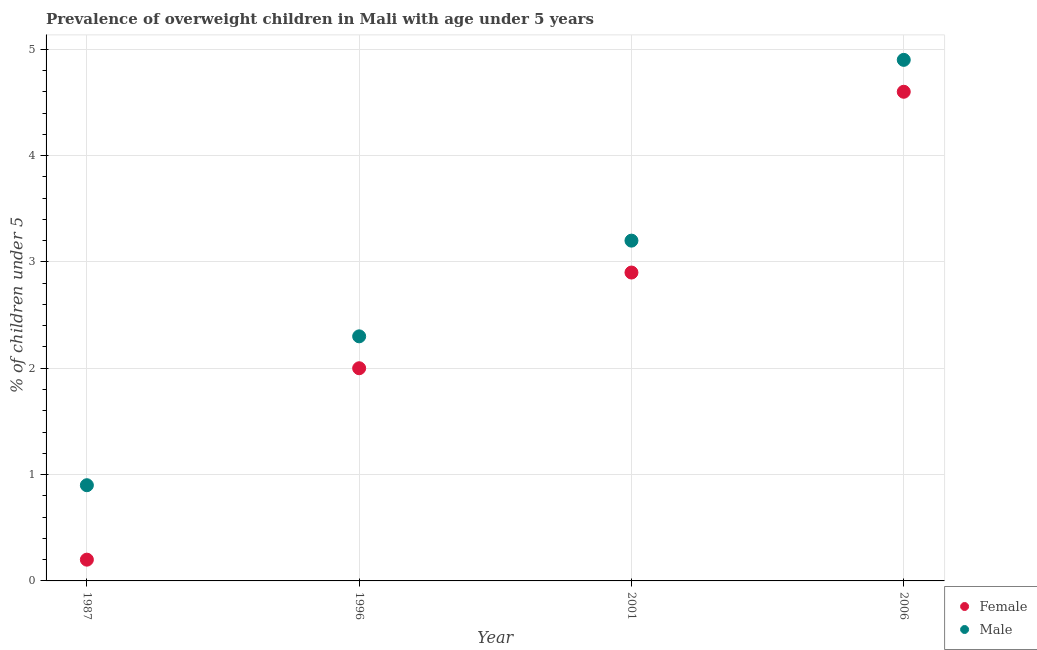How many different coloured dotlines are there?
Give a very brief answer. 2. What is the percentage of obese male children in 1996?
Keep it short and to the point. 2.3. Across all years, what is the maximum percentage of obese male children?
Give a very brief answer. 4.9. Across all years, what is the minimum percentage of obese female children?
Keep it short and to the point. 0.2. In which year was the percentage of obese male children maximum?
Give a very brief answer. 2006. In which year was the percentage of obese male children minimum?
Offer a terse response. 1987. What is the total percentage of obese male children in the graph?
Your response must be concise. 11.3. What is the difference between the percentage of obese female children in 1996 and that in 2006?
Your response must be concise. -2.6. What is the difference between the percentage of obese female children in 2001 and the percentage of obese male children in 1996?
Offer a terse response. 0.6. What is the average percentage of obese female children per year?
Offer a terse response. 2.43. In the year 1996, what is the difference between the percentage of obese male children and percentage of obese female children?
Offer a terse response. 0.3. In how many years, is the percentage of obese male children greater than 3 %?
Offer a terse response. 2. What is the ratio of the percentage of obese male children in 1996 to that in 2001?
Offer a very short reply. 0.72. Is the percentage of obese female children in 1987 less than that in 2006?
Your answer should be very brief. Yes. What is the difference between the highest and the second highest percentage of obese male children?
Give a very brief answer. 1.7. What is the difference between the highest and the lowest percentage of obese male children?
Offer a terse response. 4. Is the sum of the percentage of obese female children in 1996 and 2001 greater than the maximum percentage of obese male children across all years?
Offer a very short reply. No. Does the percentage of obese female children monotonically increase over the years?
Give a very brief answer. Yes. Is the percentage of obese male children strictly less than the percentage of obese female children over the years?
Give a very brief answer. No. How many legend labels are there?
Make the answer very short. 2. How are the legend labels stacked?
Offer a very short reply. Vertical. What is the title of the graph?
Offer a terse response. Prevalence of overweight children in Mali with age under 5 years. What is the label or title of the Y-axis?
Ensure brevity in your answer.   % of children under 5. What is the  % of children under 5 in Female in 1987?
Keep it short and to the point. 0.2. What is the  % of children under 5 of Male in 1987?
Your answer should be compact. 0.9. What is the  % of children under 5 in Male in 1996?
Provide a short and direct response. 2.3. What is the  % of children under 5 of Female in 2001?
Provide a short and direct response. 2.9. What is the  % of children under 5 in Male in 2001?
Make the answer very short. 3.2. What is the  % of children under 5 of Female in 2006?
Your answer should be very brief. 4.6. What is the  % of children under 5 in Male in 2006?
Keep it short and to the point. 4.9. Across all years, what is the maximum  % of children under 5 of Female?
Give a very brief answer. 4.6. Across all years, what is the maximum  % of children under 5 of Male?
Make the answer very short. 4.9. Across all years, what is the minimum  % of children under 5 of Female?
Keep it short and to the point. 0.2. Across all years, what is the minimum  % of children under 5 of Male?
Your answer should be very brief. 0.9. What is the difference between the  % of children under 5 in Female in 1987 and that in 1996?
Make the answer very short. -1.8. What is the difference between the  % of children under 5 in Male in 1987 and that in 1996?
Provide a succinct answer. -1.4. What is the difference between the  % of children under 5 in Male in 1987 and that in 2006?
Your response must be concise. -4. What is the difference between the  % of children under 5 in Female in 2001 and that in 2006?
Keep it short and to the point. -1.7. What is the difference between the  % of children under 5 in Female in 1987 and the  % of children under 5 in Male in 1996?
Provide a short and direct response. -2.1. What is the difference between the  % of children under 5 of Female in 1987 and the  % of children under 5 of Male in 2001?
Keep it short and to the point. -3. What is the difference between the  % of children under 5 in Female in 1987 and the  % of children under 5 in Male in 2006?
Keep it short and to the point. -4.7. What is the difference between the  % of children under 5 of Female in 1996 and the  % of children under 5 of Male in 2001?
Offer a very short reply. -1.2. What is the difference between the  % of children under 5 of Female in 1996 and the  % of children under 5 of Male in 2006?
Your answer should be compact. -2.9. What is the average  % of children under 5 of Female per year?
Your answer should be compact. 2.42. What is the average  % of children under 5 of Male per year?
Provide a short and direct response. 2.83. In the year 2001, what is the difference between the  % of children under 5 of Female and  % of children under 5 of Male?
Make the answer very short. -0.3. What is the ratio of the  % of children under 5 in Female in 1987 to that in 1996?
Ensure brevity in your answer.  0.1. What is the ratio of the  % of children under 5 in Male in 1987 to that in 1996?
Offer a terse response. 0.39. What is the ratio of the  % of children under 5 of Female in 1987 to that in 2001?
Your answer should be compact. 0.07. What is the ratio of the  % of children under 5 of Male in 1987 to that in 2001?
Provide a succinct answer. 0.28. What is the ratio of the  % of children under 5 of Female in 1987 to that in 2006?
Your answer should be compact. 0.04. What is the ratio of the  % of children under 5 of Male in 1987 to that in 2006?
Your response must be concise. 0.18. What is the ratio of the  % of children under 5 of Female in 1996 to that in 2001?
Offer a very short reply. 0.69. What is the ratio of the  % of children under 5 in Male in 1996 to that in 2001?
Provide a succinct answer. 0.72. What is the ratio of the  % of children under 5 of Female in 1996 to that in 2006?
Offer a terse response. 0.43. What is the ratio of the  % of children under 5 of Male in 1996 to that in 2006?
Your answer should be very brief. 0.47. What is the ratio of the  % of children under 5 in Female in 2001 to that in 2006?
Offer a very short reply. 0.63. What is the ratio of the  % of children under 5 of Male in 2001 to that in 2006?
Give a very brief answer. 0.65. What is the difference between the highest and the second highest  % of children under 5 of Female?
Keep it short and to the point. 1.7. What is the difference between the highest and the second highest  % of children under 5 of Male?
Offer a terse response. 1.7. What is the difference between the highest and the lowest  % of children under 5 in Female?
Make the answer very short. 4.4. What is the difference between the highest and the lowest  % of children under 5 in Male?
Your response must be concise. 4. 